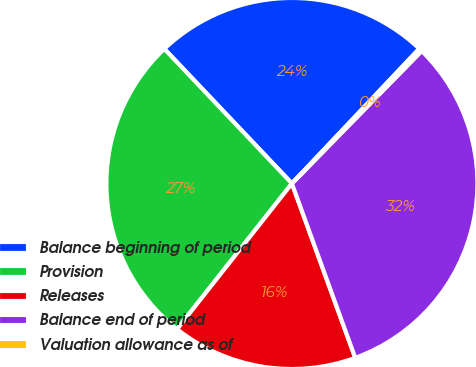Convert chart. <chart><loc_0><loc_0><loc_500><loc_500><pie_chart><fcel>Balance beginning of period<fcel>Provision<fcel>Releases<fcel>Balance end of period<fcel>Valuation allowance as of<nl><fcel>24.12%<fcel>27.3%<fcel>16.17%<fcel>32.12%<fcel>0.28%<nl></chart> 